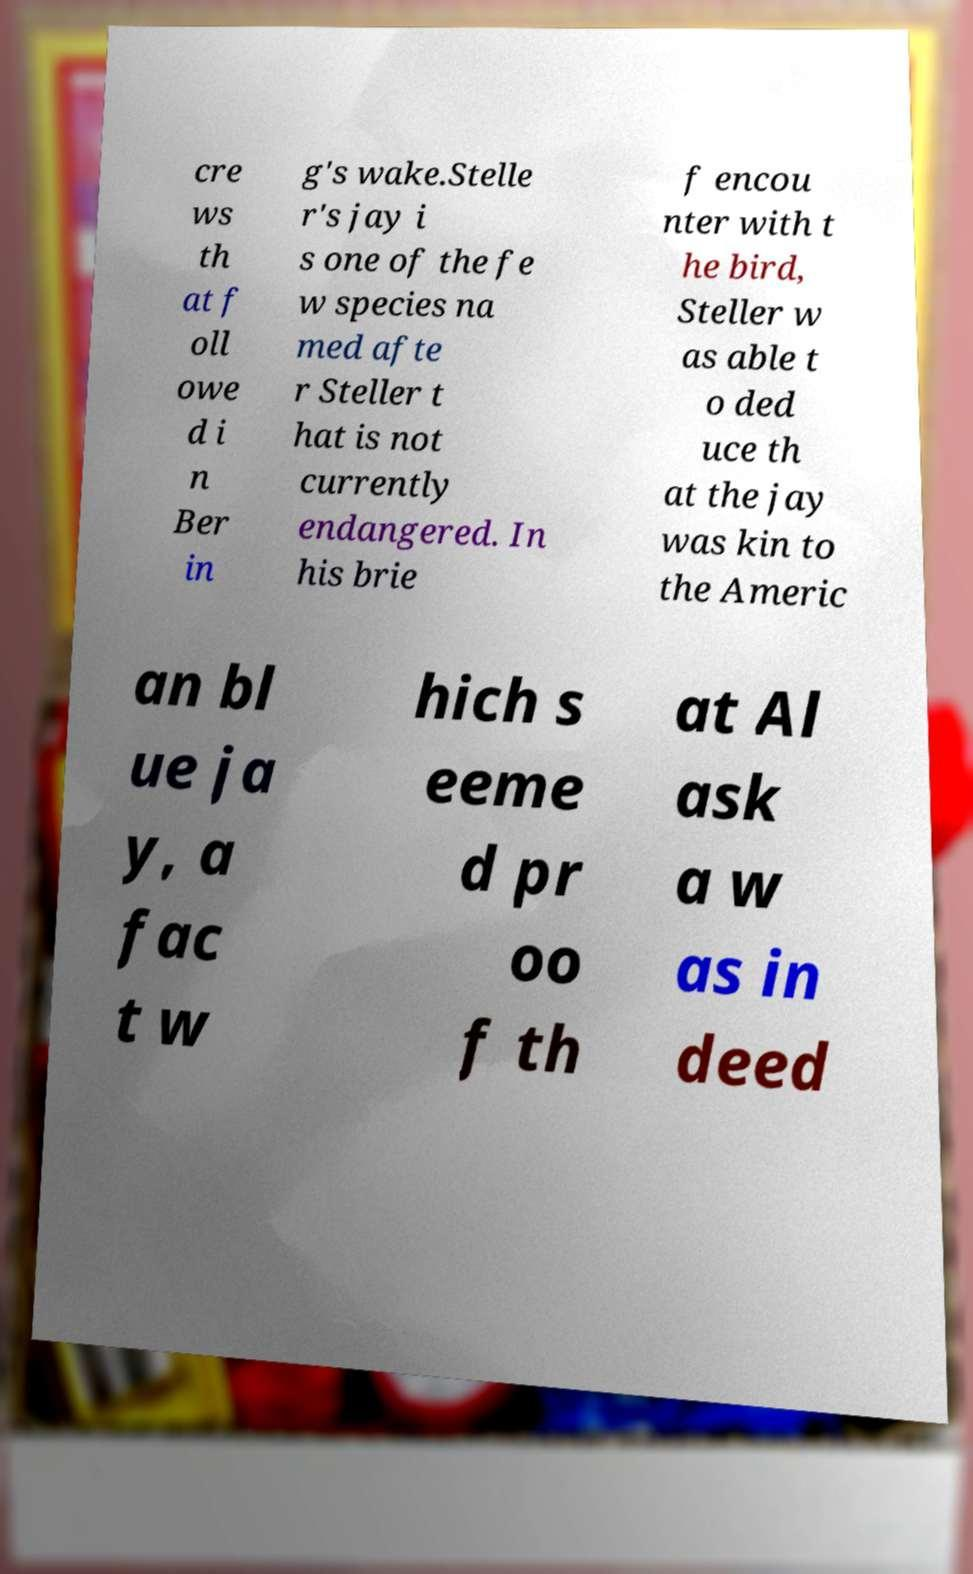Please read and relay the text visible in this image. What does it say? cre ws th at f oll owe d i n Ber in g's wake.Stelle r's jay i s one of the fe w species na med afte r Steller t hat is not currently endangered. In his brie f encou nter with t he bird, Steller w as able t o ded uce th at the jay was kin to the Americ an bl ue ja y, a fac t w hich s eeme d pr oo f th at Al ask a w as in deed 